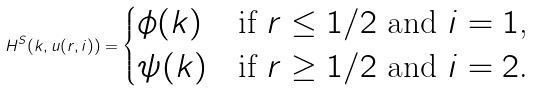<formula> <loc_0><loc_0><loc_500><loc_500>H ^ { S } ( k , u ( r , i ) ) = \begin{cases} \phi ( k ) & \text {if $r\leq 1/2$ and $i=1$,} \\ \psi ( k ) & \text {if $r\geq 1/2$ and $i=2$.} \end{cases}</formula> 